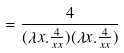<formula> <loc_0><loc_0><loc_500><loc_500>= \frac { 4 } { ( \lambda x . \frac { 4 } { x x } ) ( \lambda x . \frac { 4 } { x x } ) }</formula> 